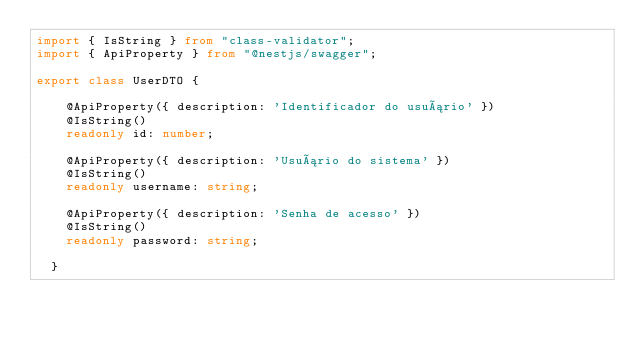<code> <loc_0><loc_0><loc_500><loc_500><_TypeScript_>import { IsString } from "class-validator";
import { ApiProperty } from "@nestjs/swagger";

export class UserDTO {

    @ApiProperty({ description: 'Identificador do usuário' })
    @IsString()
    readonly id: number;

    @ApiProperty({ description: 'Usuário do sistema' })
    @IsString()
    readonly username: string;
  
    @ApiProperty({ description: 'Senha de acesso' })
    @IsString()
    readonly password: string;
  
  }</code> 